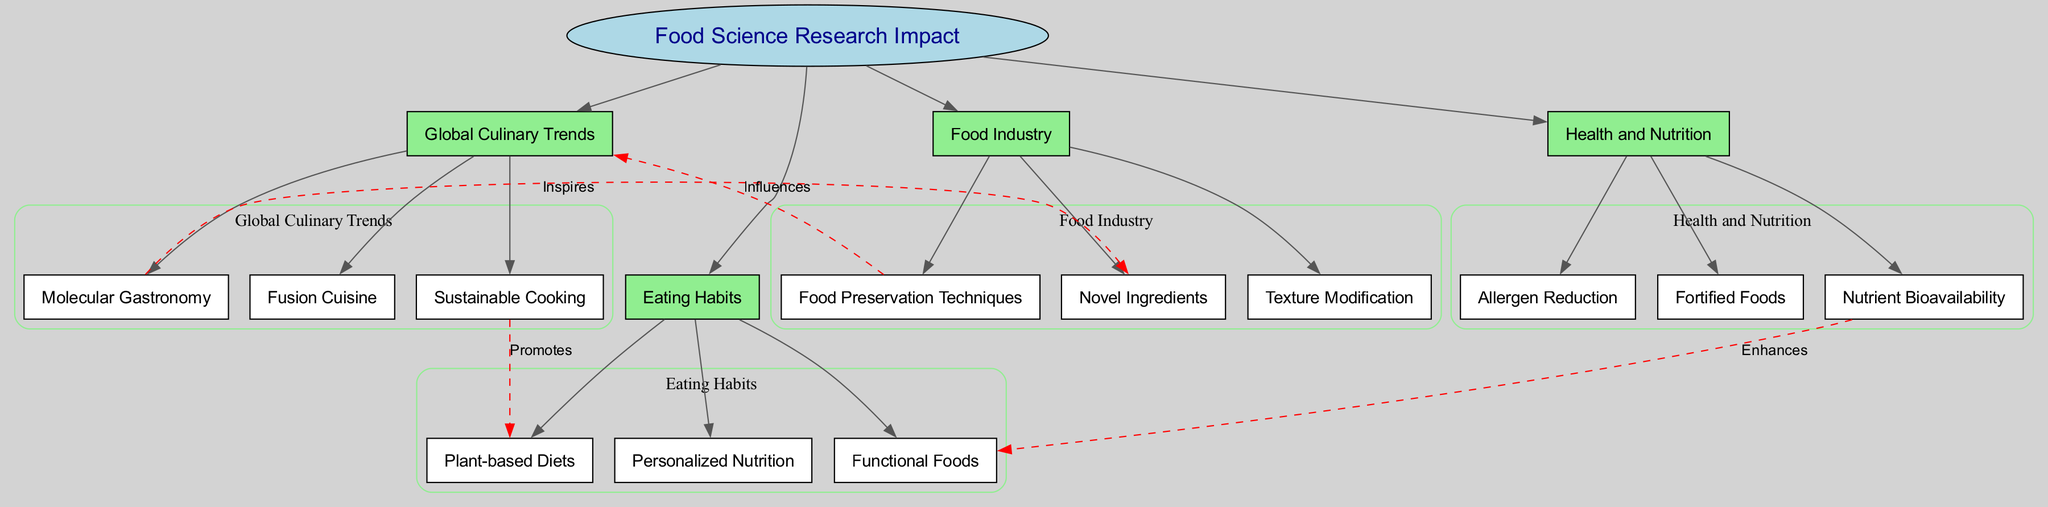What is the central concept of the diagram? The central concept is displayed prominently at the center of the diagram, surrounded by the main branches. It is clearly labeled as "Food Science Research Impact."
Answer: Food Science Research Impact How many main branches are there? Counting the branches that directly connect to the central concept, there are four main branches listed, which are distinct and clearly categorized.
Answer: 4 What does "Molecular Gastronomy" inspire? The label on the connecting edge indicates that "Molecular Gastronomy" directly inspires "Novel Ingredients," which is shown in the diagram with a dashed line.
Answer: Novel Ingredients Which sub-branch does "Sustainable Cooking" promote? Referencing the connection, "Sustainable Cooking" is linked to "Plant-based Diets," meaning that it promotes this specific eating habit.
Answer: Plant-based Diets What influences "Global Culinary Trends"? The diagram shows that "Food Preservation Techniques" influences the main branch of "Global Culinary Trends," which is marked by a dashed connection.
Answer: Food Preservation Techniques Which two concepts are connected by the label "Enhances"? The connection labeled "Enhances" directly connects "Nutrient Bioavailability" and "Functional Foods," indicating a relationship between these two concepts.
Answer: Nutrient Bioavailability and Functional Foods Name one of the sub-branches under "Health and Nutrition." Under "Health and Nutrition," there are several sub-branches listed, one of which can be easily identified through labeling. For instance, "Fortified Foods" is clearly shown.
Answer: Fortified Foods How does "Sustainable Cooking" relate to "Eating Habits"? The connection described in the diagram shows that "Sustainable Cooking" promotes "Plant-based Diets," which is a direct relationship affecting eating habits.
Answer: Promotes Plant-based Diets What is the relationship between "Molecular Gastronomy" and "Global Culinary Trends"? While "Molecular Gastronomy" does not directly connect to "Global Culinary Trends," it inspires novel ingredients which can subsequently influence culinary trends; this requires understanding multiple connections within the diagram.
Answer: Inspires Novel Ingredients What type of foods do personalized nutrition trends focus on? "Personalized Nutrition," as shown in the diagram, falls under the broader eating habits influenced by food science research; it relates to specific dietary adjustments suited to individual needs.
Answer: Functional Foods 